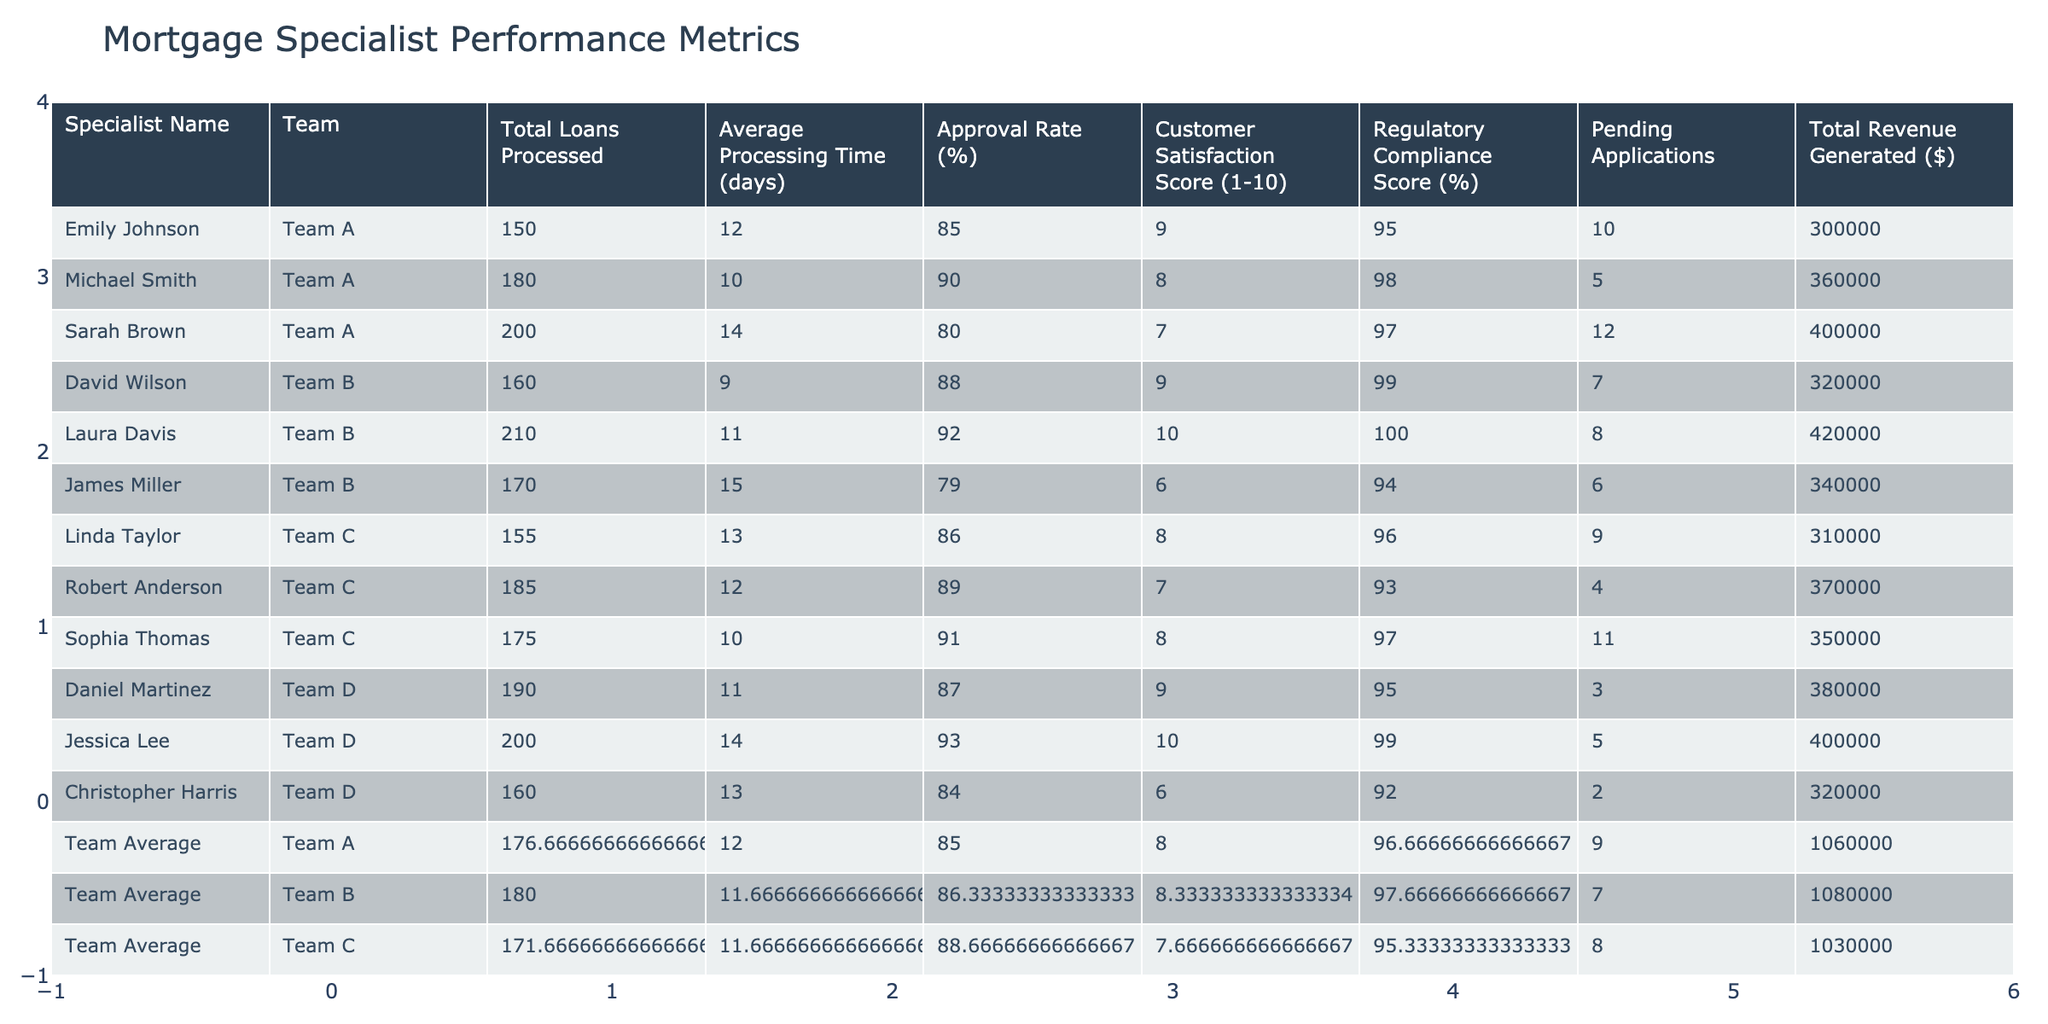What is the average processing time for Team B? Team B has three specialists: David Wilson, Laura Davis, and James Miller, with processing times of 9, 11, and 15 days respectively. The average is calculated by summing these values (9 + 11 + 15 = 35) and dividing by the number of specialists (35 / 3 ≈ 11.67).
Answer: 11.67 days Which specialist generated the highest total revenue? The total revenue generated by each specialist is as follows: Emily Johnson ($300,000), Michael Smith ($360,000), Sarah Brown ($400,000), David Wilson ($320,000), Laura Davis ($420,000), James Miller ($340,000), Linda Taylor ($310,000), Robert Anderson ($370,000), Sophia Thomas ($350,000), Daniel Martinez ($380,000), Jessica Lee ($400,000), and Christopher Harris ($320,000). Among these, Laura Davis generated the highest revenue of $420,000.
Answer: Laura Davis What is the approval rate of the team with the lowest customer satisfaction score? Looking at the customer satisfaction scores, Team B has scores of 9, 10, and 6, making it the team with the lowest maximum score which corresponds to James Miller (6). James Miller's approval rate is 79%, so Team B's approval rate is the average of 88, 92, and 79, which totals to 86.33%.
Answer: 86.33% Are all the specialists in Team D meeting regulatory compliance standards of 90% or above? The regulatory compliance scores for Team D specialists are: Daniel Martinez (95%), Jessica Lee (99%), and Christopher Harris (92%). All scores are above 90%, confirming that yes, all specialists meet the standards.
Answer: Yes What is the total number of pending applications for specialists in Team A? The pending applications for Team A specialists: Emily Johnson has 10, Michael Smith has 5, and Sarah Brown has 12. Adding these together gives 10 + 5 + 12 = 27 pending applications.
Answer: 27 What is the overall team average for total loans processed? The total loans processed by all specialists are 150 (Emily) + 180 (Michael) + 200 (Sarah) + 160 (David) + 210 (Laura) + 170 (James) + 155 (Linda) + 185 (Robert) + 175 (Sophia) + 190 (Daniel) + 200 (Jessica) + 160 (Christopher), which sums to 2,080. There are 12 individuals total, so the team average is 2,080 / 12 ≈ 173.33.
Answer: 173.33 Which team has the highest average approval rate? The average approval rates for each team are calculated: Team A (85.00%), Team B (86.33%), Team C (88.67%), Team D (88.33%). Comparing these, Team C has the highest average approval rate of 88.67%.
Answer: Team C How does Sarah Brown's customer satisfaction score compare to the team average for Team A? Sarah Brown has a customer satisfaction score of 7. Team A's average customer satisfaction score is calculated as (9 + 8 + 7) / 3 = 8. Since 7 is lower than the team average of 8, it indicates Sarah's score is below average.
Answer: Below average What percentage of total loans processed does Team D contribute? Total loans processed across all teams: 2,080. Team D's total is 200 (Daniel) + 190 (Jessica) + 160 (Christopher) = 550. The contribution percentage is (550 / 2080) * 100 ≈ 26.44%.
Answer: 26.44% Is there any specialist in Team C with a customer satisfaction score lower than 8? The customer satisfaction scores for Team C specialists are: Linda Taylor (8), Robert Anderson (7), and Sophia Thomas (8). Robert Anderson's score of 7 is lower than 8.
Answer: Yes 